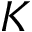Convert formula to latex. <formula><loc_0><loc_0><loc_500><loc_500>K</formula> 